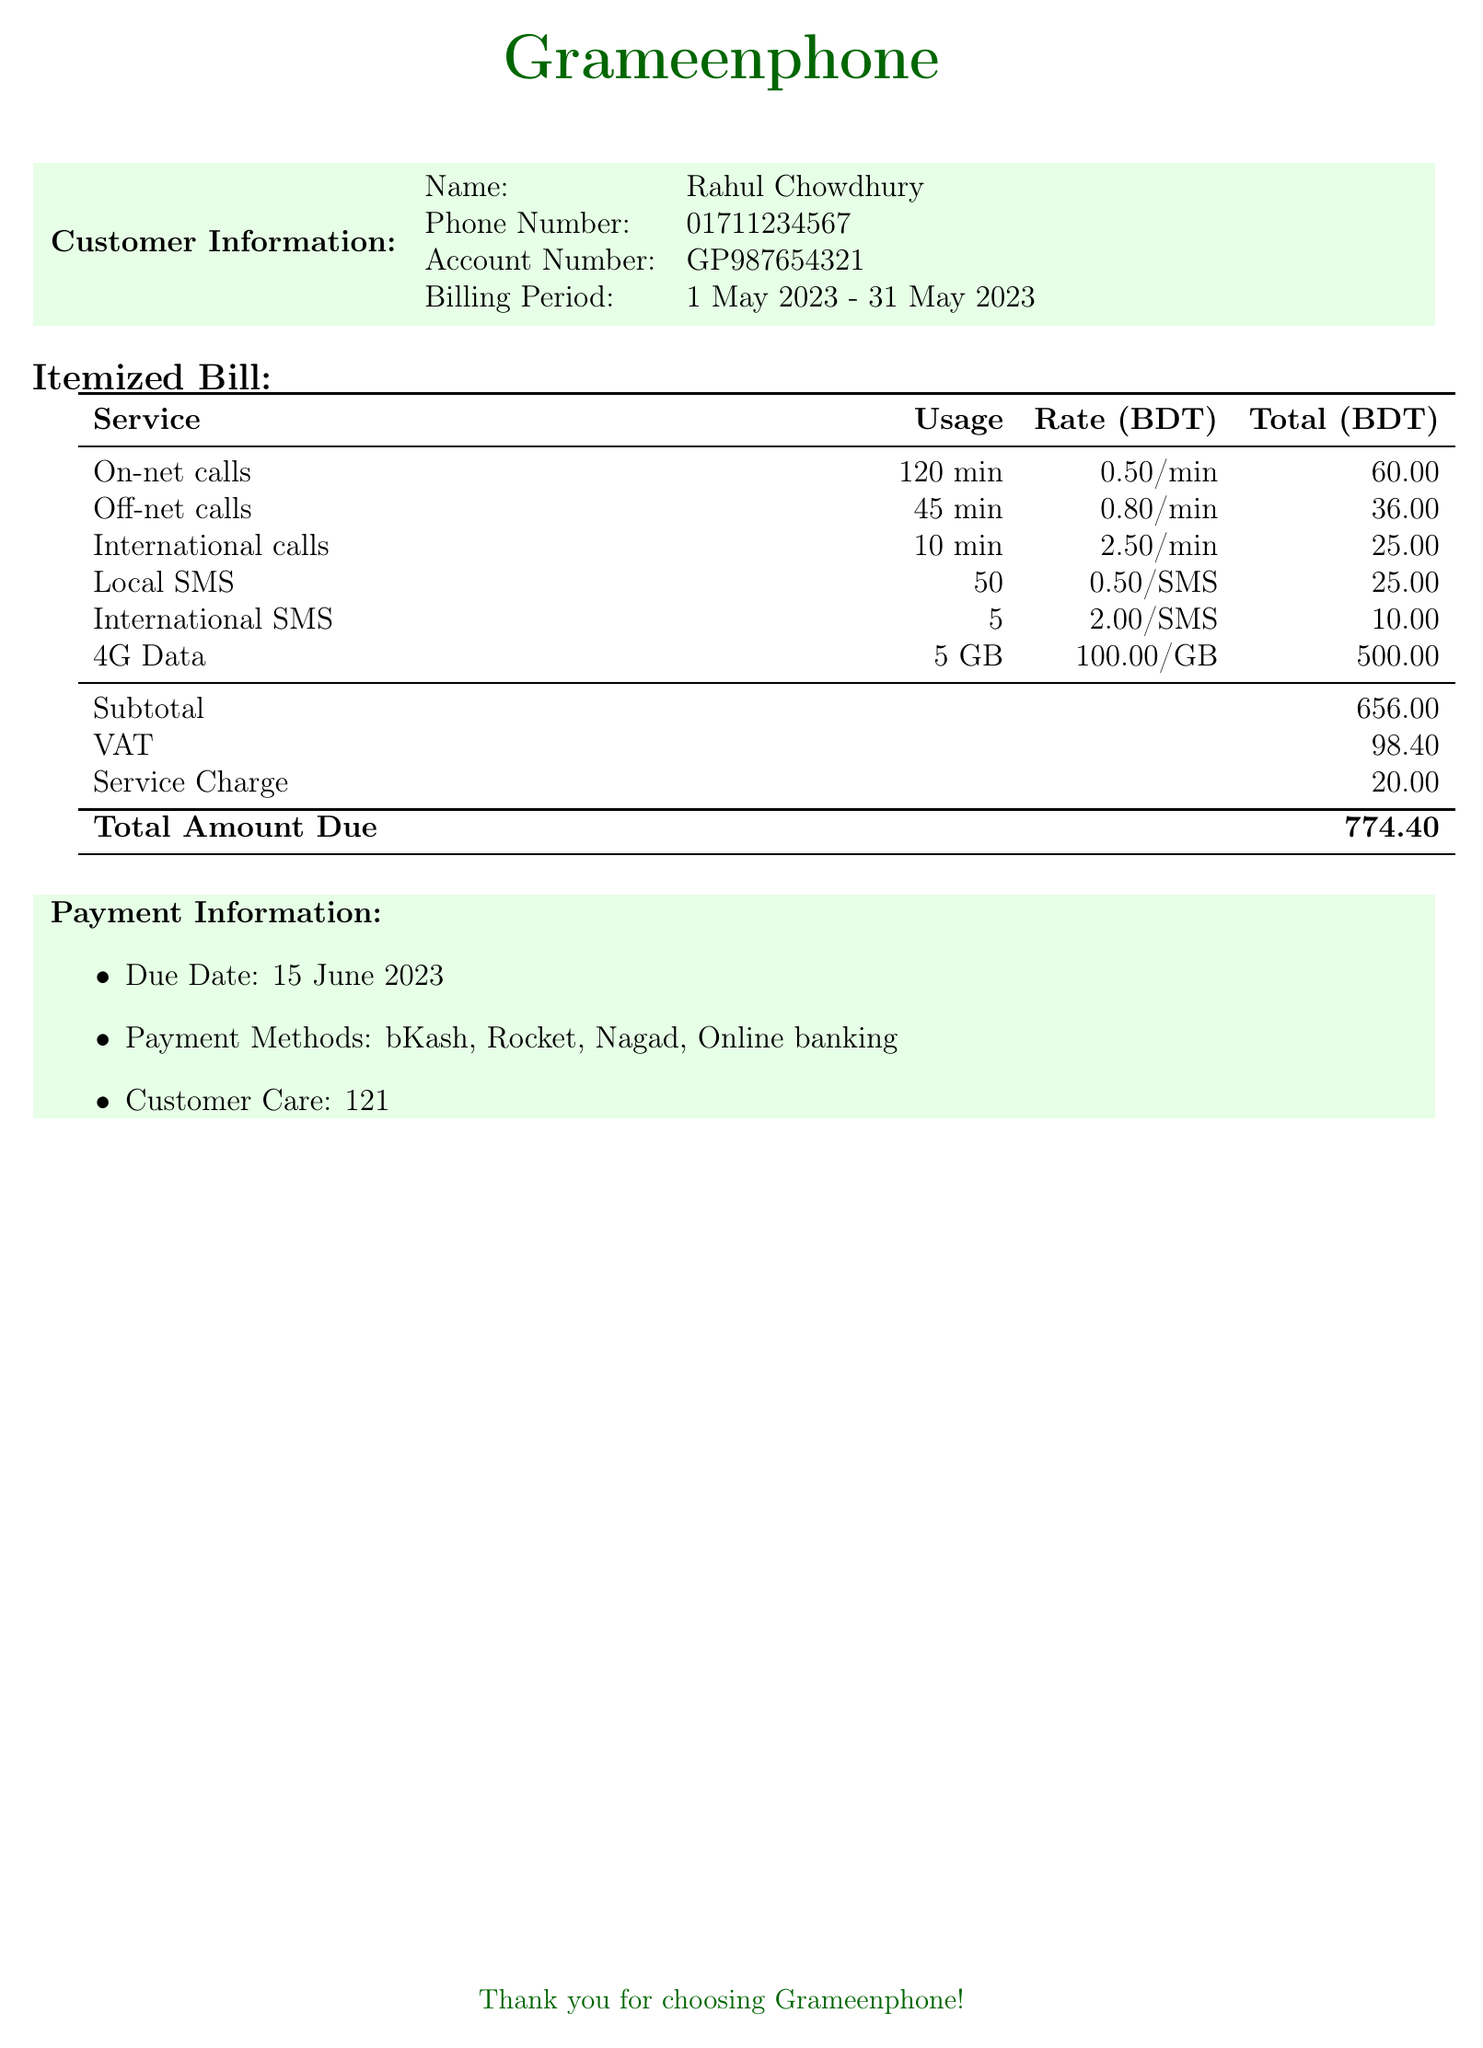What is the name of the customer? The document explicitly states the name of the customer, which is listed under Customer Information.
Answer: Rahul Chowdhury What is the total amount due? The total amount due is indicated at the bottom of the itemized bill and represents the final total.
Answer: 774.40 How many local SMS were sent? The document specifies the number of local SMS sent in the itemized bill section.
Answer: 50 What is the billing period? The billing period is provided in the Customer Information section, detailing the start and end dates.
Answer: 1 May 2023 - 31 May 2023 What is the service charge? The service charge is listed within the subtotals in the itemized bill section.
Answer: 20.00 What is the VAT amount? The VAT amount is explicitly stated in the itemized bill after subtotals.
Answer: 98.40 How many minutes of international calls were made? The number of international call minutes used is detailed in the itemized bill.
Answer: 10 min Which payment methods are available? The available payment methods are listed under Payment Information in the document.
Answer: bKash, Rocket, Nagad, Online banking What is the due date for payment? The due date is specified in the Payment Information section of the document.
Answer: 15 June 2023 